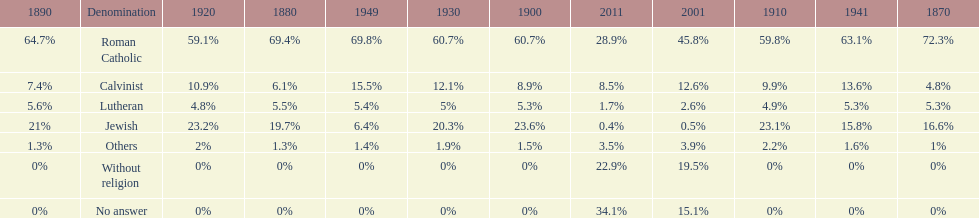What is the largest religious denomination in budapest? Roman Catholic. 